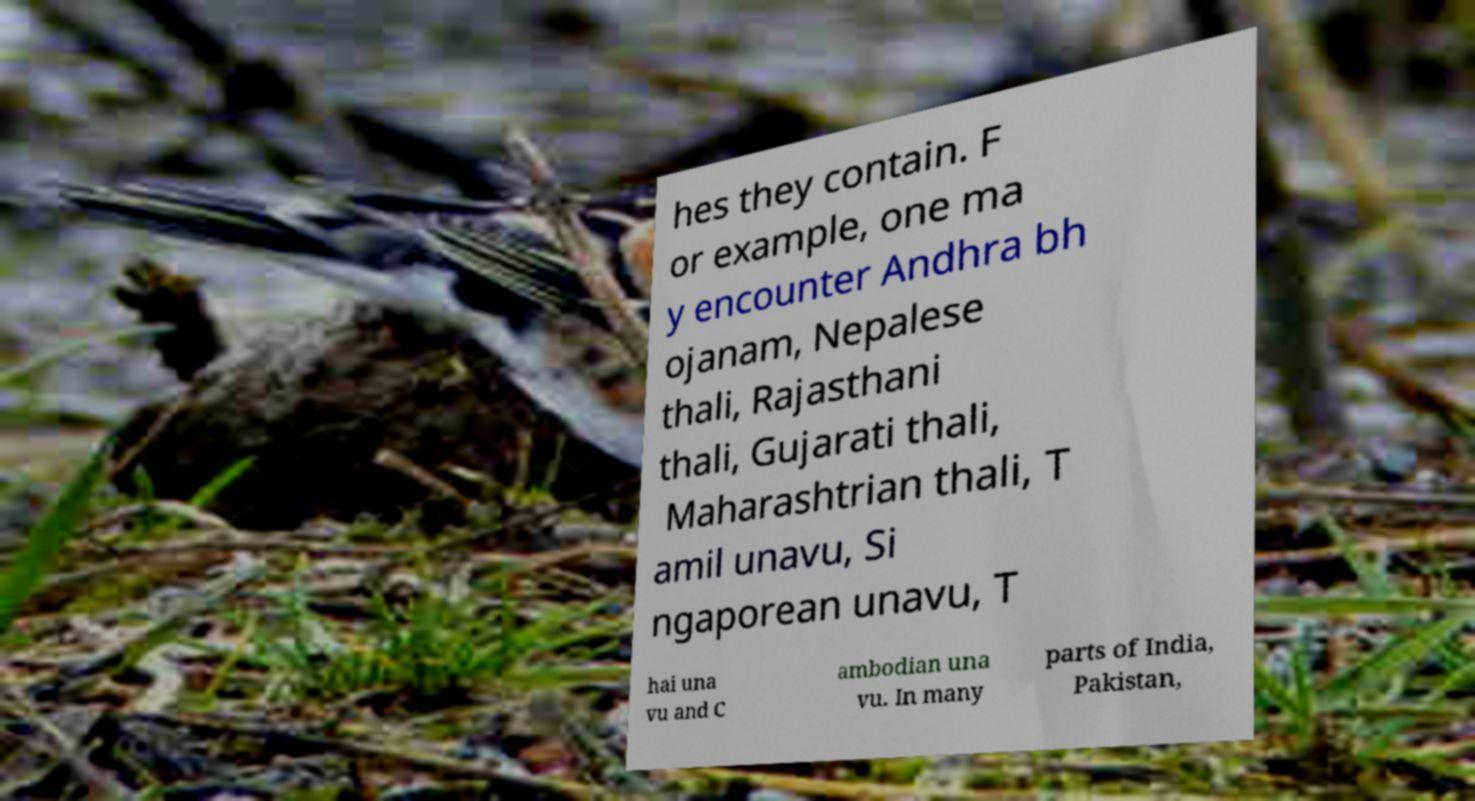Can you read and provide the text displayed in the image?This photo seems to have some interesting text. Can you extract and type it out for me? hes they contain. F or example, one ma y encounter Andhra bh ojanam, Nepalese thali, Rajasthani thali, Gujarati thali, Maharashtrian thali, T amil unavu, Si ngaporean unavu, T hai una vu and C ambodian una vu. In many parts of India, Pakistan, 